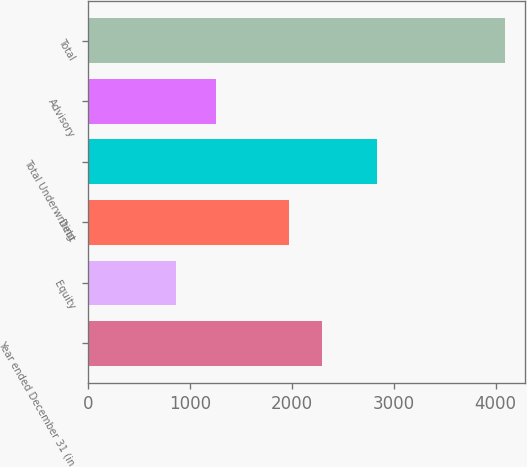<chart> <loc_0><loc_0><loc_500><loc_500><bar_chart><fcel>Year ended December 31 (in<fcel>Equity<fcel>Debt<fcel>Total Underwriting<fcel>Advisory<fcel>Total<nl><fcel>2291.4<fcel>864<fcel>1969<fcel>2833<fcel>1255<fcel>4088<nl></chart> 